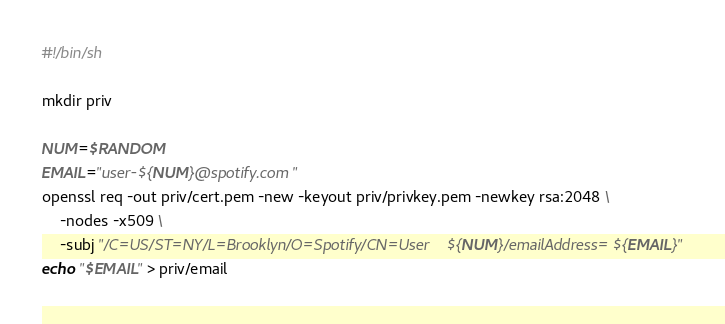Convert code to text. <code><loc_0><loc_0><loc_500><loc_500><_Bash_>#!/bin/sh

mkdir priv

NUM=$RANDOM
EMAIL="user-${NUM}@spotify.com"
openssl req -out priv/cert.pem -new -keyout priv/privkey.pem -newkey rsa:2048 \
    -nodes -x509 \
    -subj "/C=US/ST=NY/L=Brooklyn/O=Spotify/CN=User ${NUM}/emailAddress=${EMAIL}"
echo "$EMAIL" > priv/email
</code> 